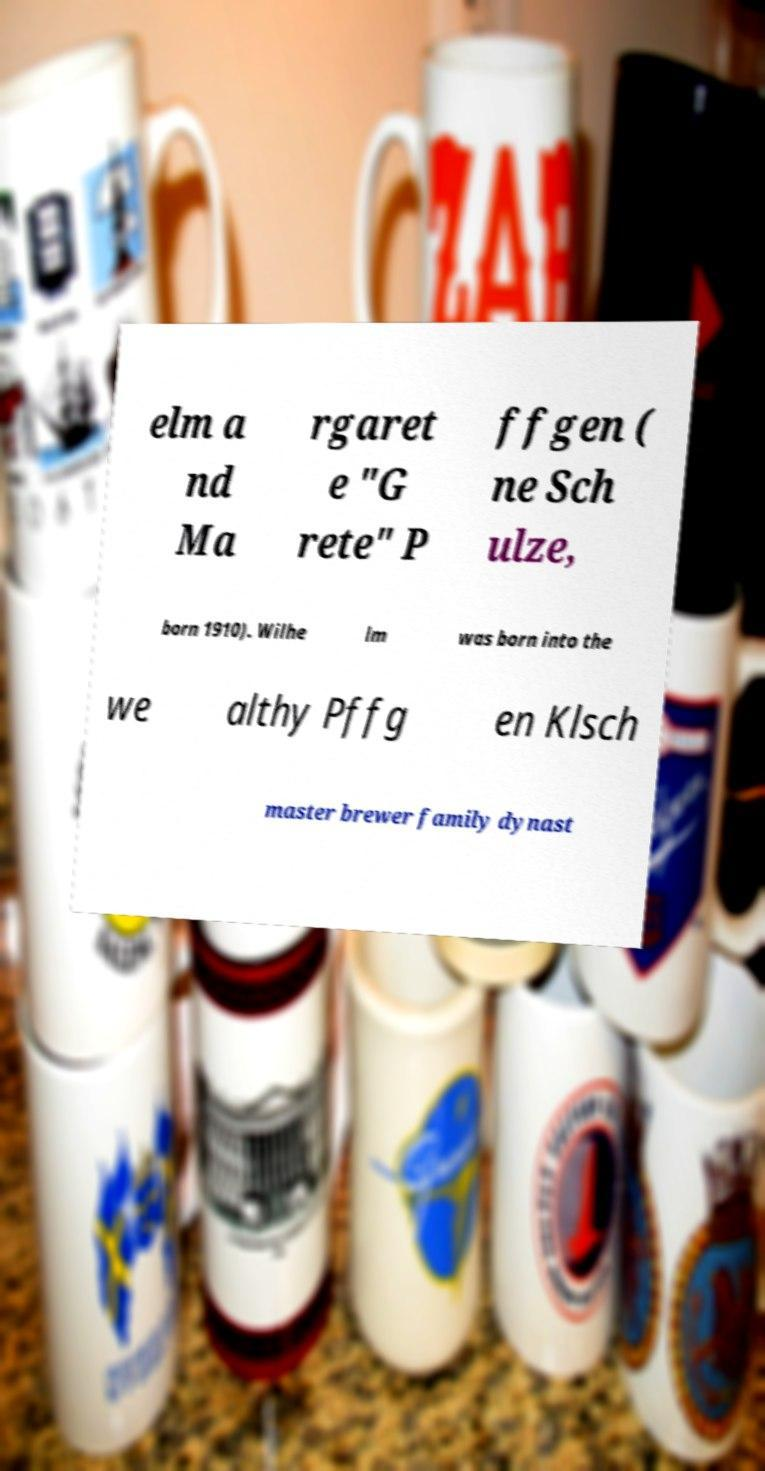What messages or text are displayed in this image? I need them in a readable, typed format. elm a nd Ma rgaret e "G rete" P ffgen ( ne Sch ulze, born 1910). Wilhe lm was born into the we althy Pffg en Klsch master brewer family dynast 